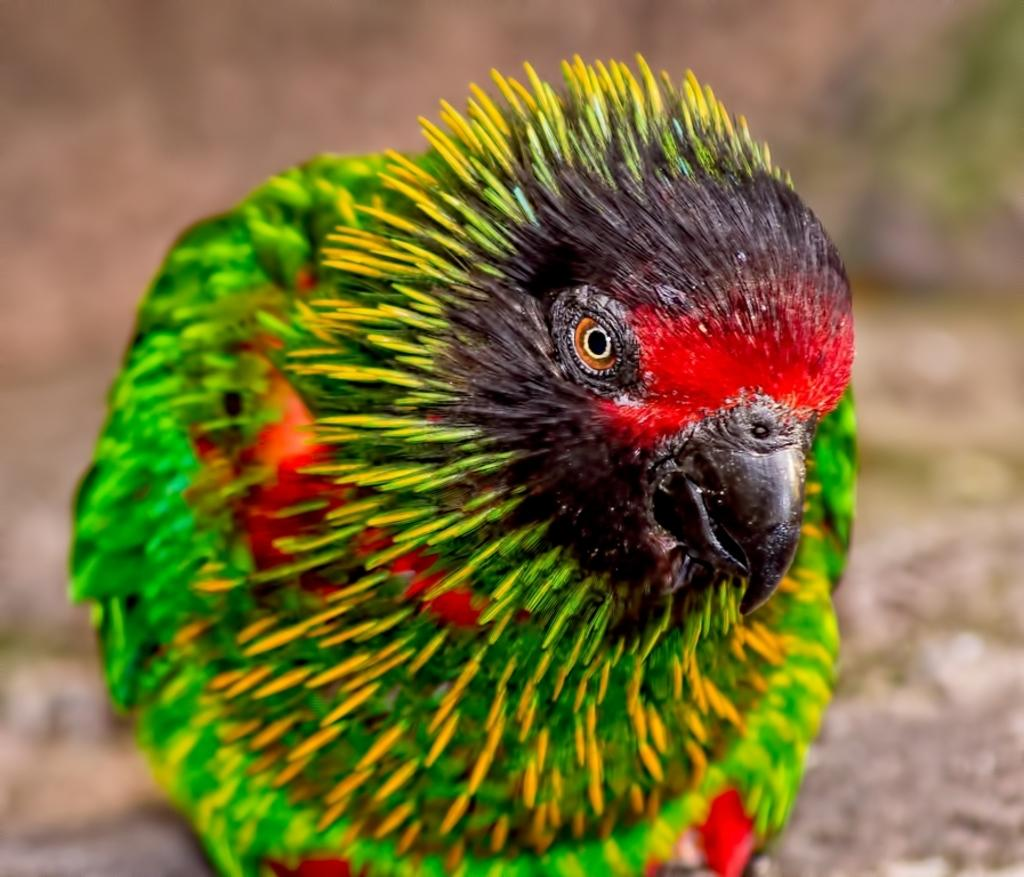What type of animal is in the image? There is a bird in the image. What colors can be seen on the bird? The bird has green, yellow, red, and brown colors. How is the bird positioned in the image? The bird is blurred in the background. How many birds are in the flock in the image? There is no flock of birds present in the image; it features a single bird. What type of receipt can be seen in the image? There is no receipt present in the image. 